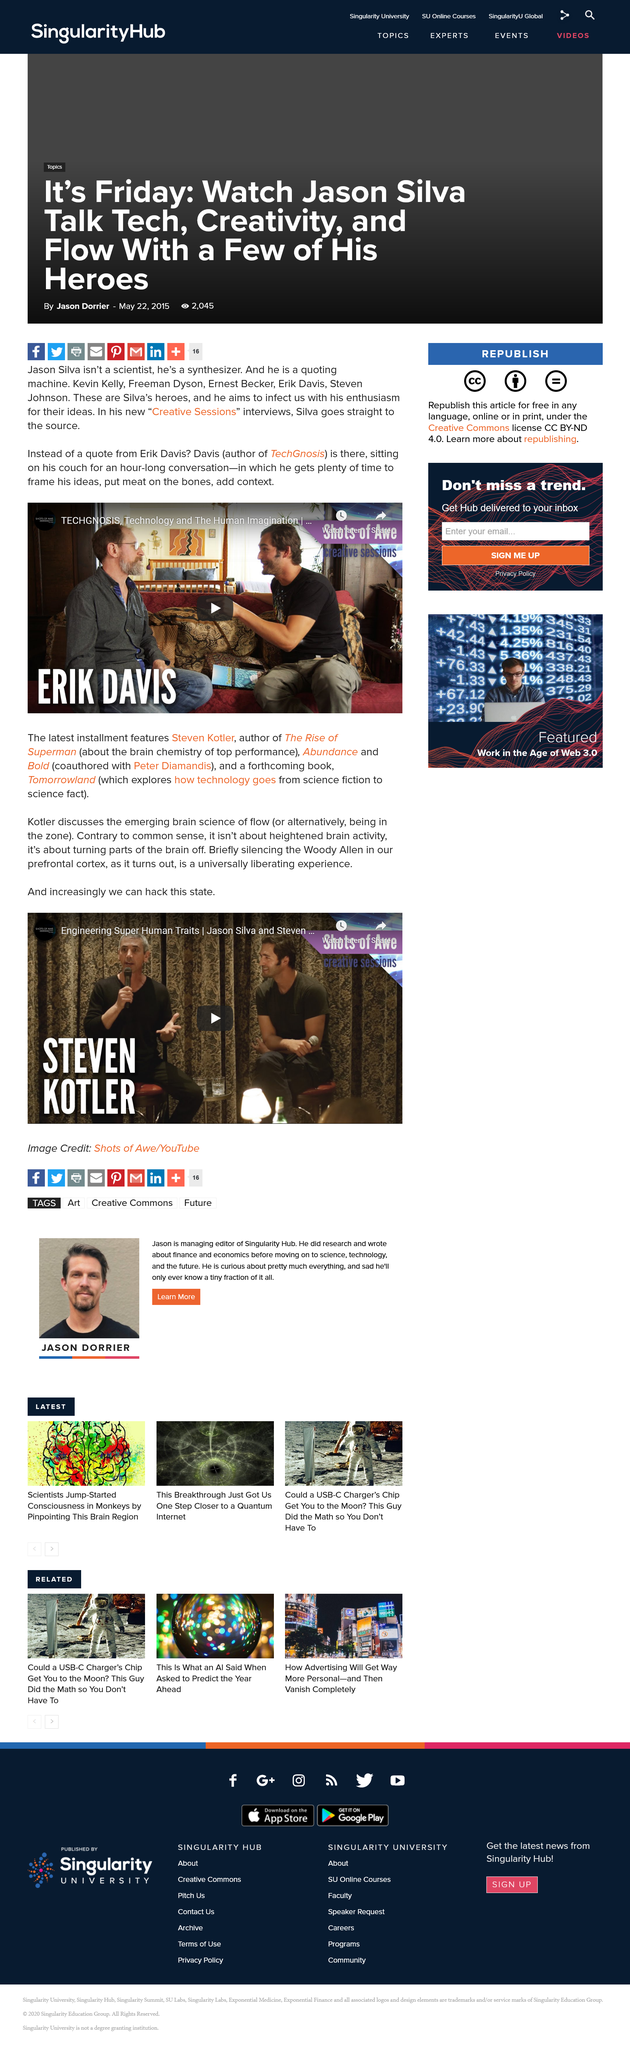Specify some key components in this picture. Flow, also known as being in the zone, is the alternative name for the science of achieving a state of optimal experience while performing an activity. The book, titled 'TechGnosis' and authored by Erik Davis, is named. Steve Kotler is the author of "The Rise of Superman." Steven Kotler's upcoming book is titled "Tomorrowland. Jason Silva has been interviewed in a new series called "Creative Sessions," where he discusses his thoughts and ideas on creativity and innovation. 